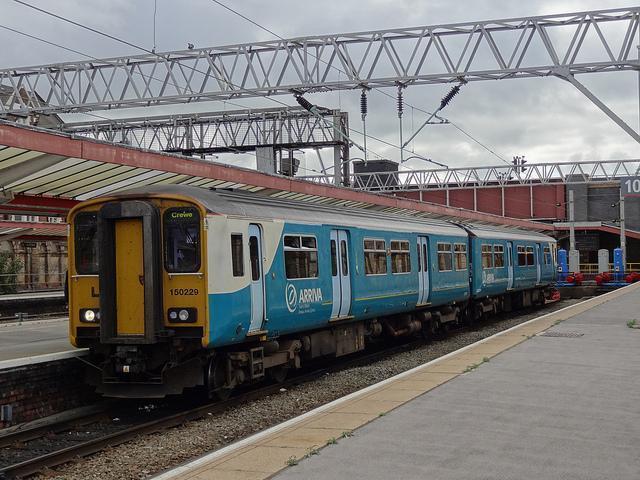How many sets of tracks?
Give a very brief answer. 2. 